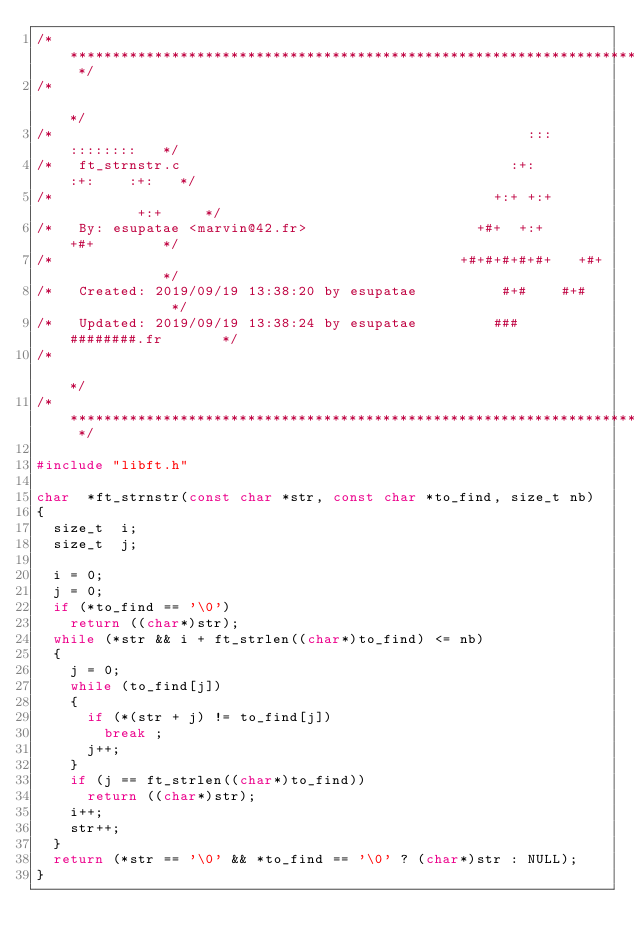<code> <loc_0><loc_0><loc_500><loc_500><_C_>/* ************************************************************************** */
/*                                                                            */
/*                                                        :::      ::::::::   */
/*   ft_strnstr.c                                       :+:      :+:    :+:   */
/*                                                    +:+ +:+         +:+     */
/*   By: esupatae <marvin@42.fr>                    +#+  +:+       +#+        */
/*                                                +#+#+#+#+#+   +#+           */
/*   Created: 2019/09/19 13:38:20 by esupatae          #+#    #+#             */
/*   Updated: 2019/09/19 13:38:24 by esupatae         ###   ########.fr       */
/*                                                                            */
/* ************************************************************************** */

#include "libft.h"

char	*ft_strnstr(const char *str, const char *to_find, size_t nb)
{
	size_t	i;
	size_t	j;

	i = 0;
	j = 0;
	if (*to_find == '\0')
		return ((char*)str);
	while (*str && i + ft_strlen((char*)to_find) <= nb)
	{
		j = 0;
		while (to_find[j])
		{
			if (*(str + j) != to_find[j])
				break ;
			j++;
		}
		if (j == ft_strlen((char*)to_find))
			return ((char*)str);
		i++;
		str++;
	}
	return (*str == '\0' && *to_find == '\0' ? (char*)str : NULL);
}
</code> 